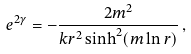Convert formula to latex. <formula><loc_0><loc_0><loc_500><loc_500>e ^ { 2 \gamma } = - \frac { 2 m ^ { 2 } } { k r ^ { 2 } \sinh ^ { 2 } ( m \ln r ) } \, ,</formula> 